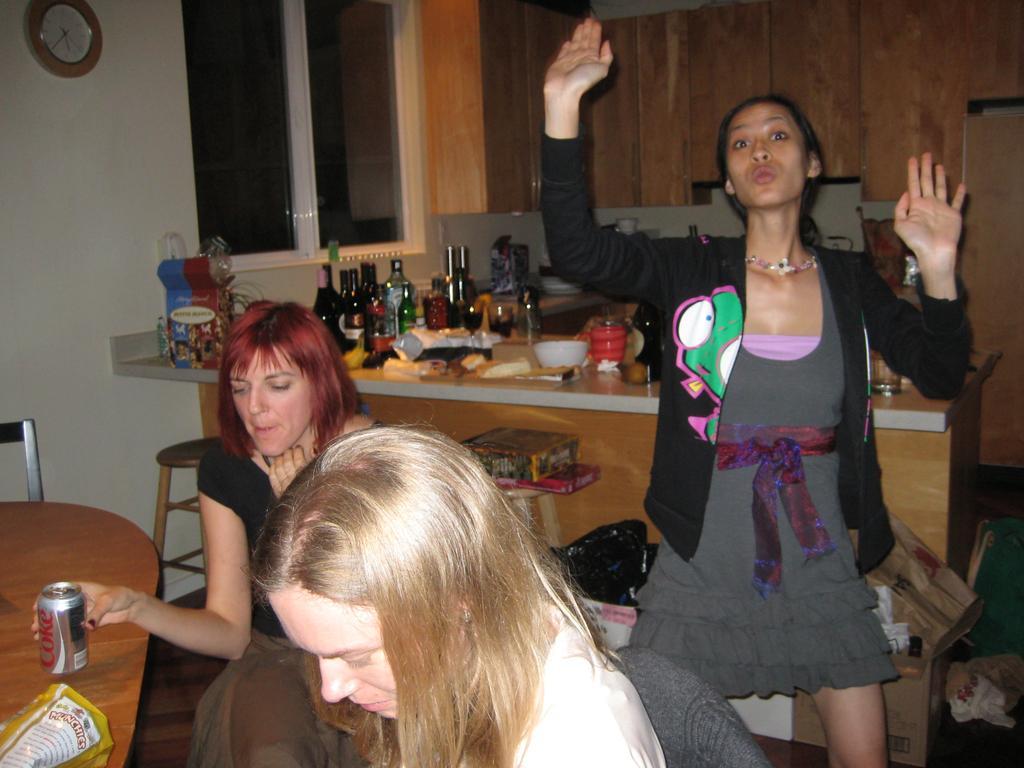Could you give a brief overview of what you see in this image? In this image I can see two persons sitting on the chair. Background I can see the other person dancing wearing black color shirt. I can also see few bottles, bowls, food on the counter top. Background I can see a clock attached to the wall and the wall is in white color. 